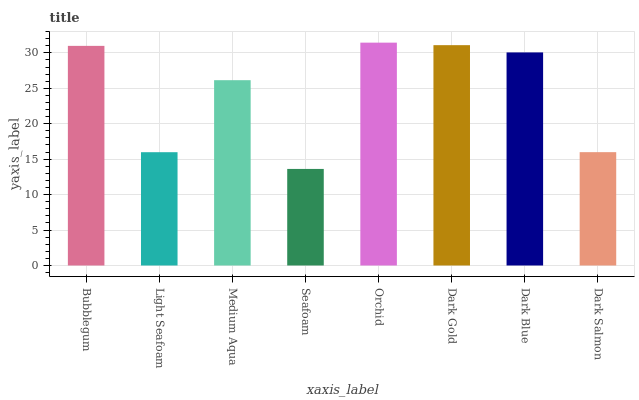Is Seafoam the minimum?
Answer yes or no. Yes. Is Orchid the maximum?
Answer yes or no. Yes. Is Light Seafoam the minimum?
Answer yes or no. No. Is Light Seafoam the maximum?
Answer yes or no. No. Is Bubblegum greater than Light Seafoam?
Answer yes or no. Yes. Is Light Seafoam less than Bubblegum?
Answer yes or no. Yes. Is Light Seafoam greater than Bubblegum?
Answer yes or no. No. Is Bubblegum less than Light Seafoam?
Answer yes or no. No. Is Dark Blue the high median?
Answer yes or no. Yes. Is Medium Aqua the low median?
Answer yes or no. Yes. Is Dark Gold the high median?
Answer yes or no. No. Is Dark Gold the low median?
Answer yes or no. No. 